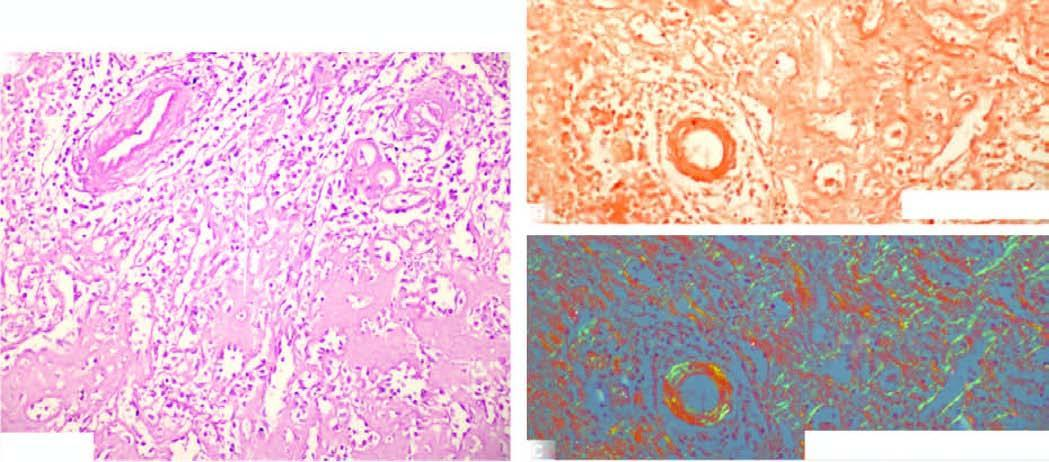does each fibril show apple-green birefringence?
Answer the question using a single word or phrase. No 